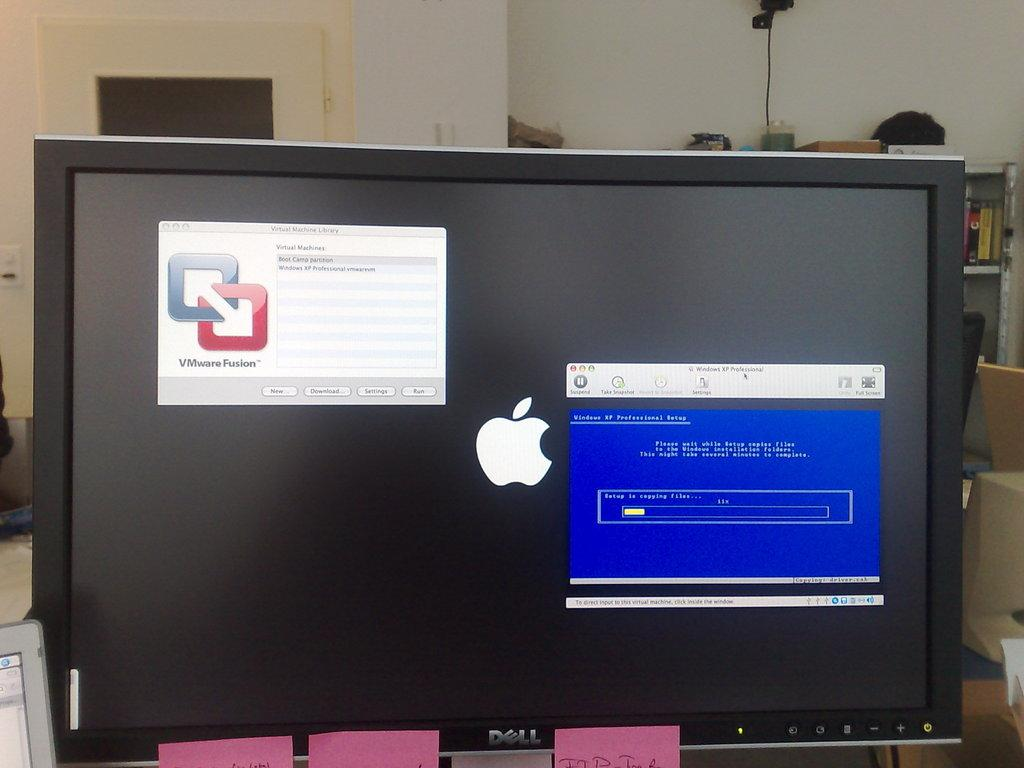<image>
Create a compact narrative representing the image presented. Dell computer monitor with a dark screen and a popup for VMware Fusion. 